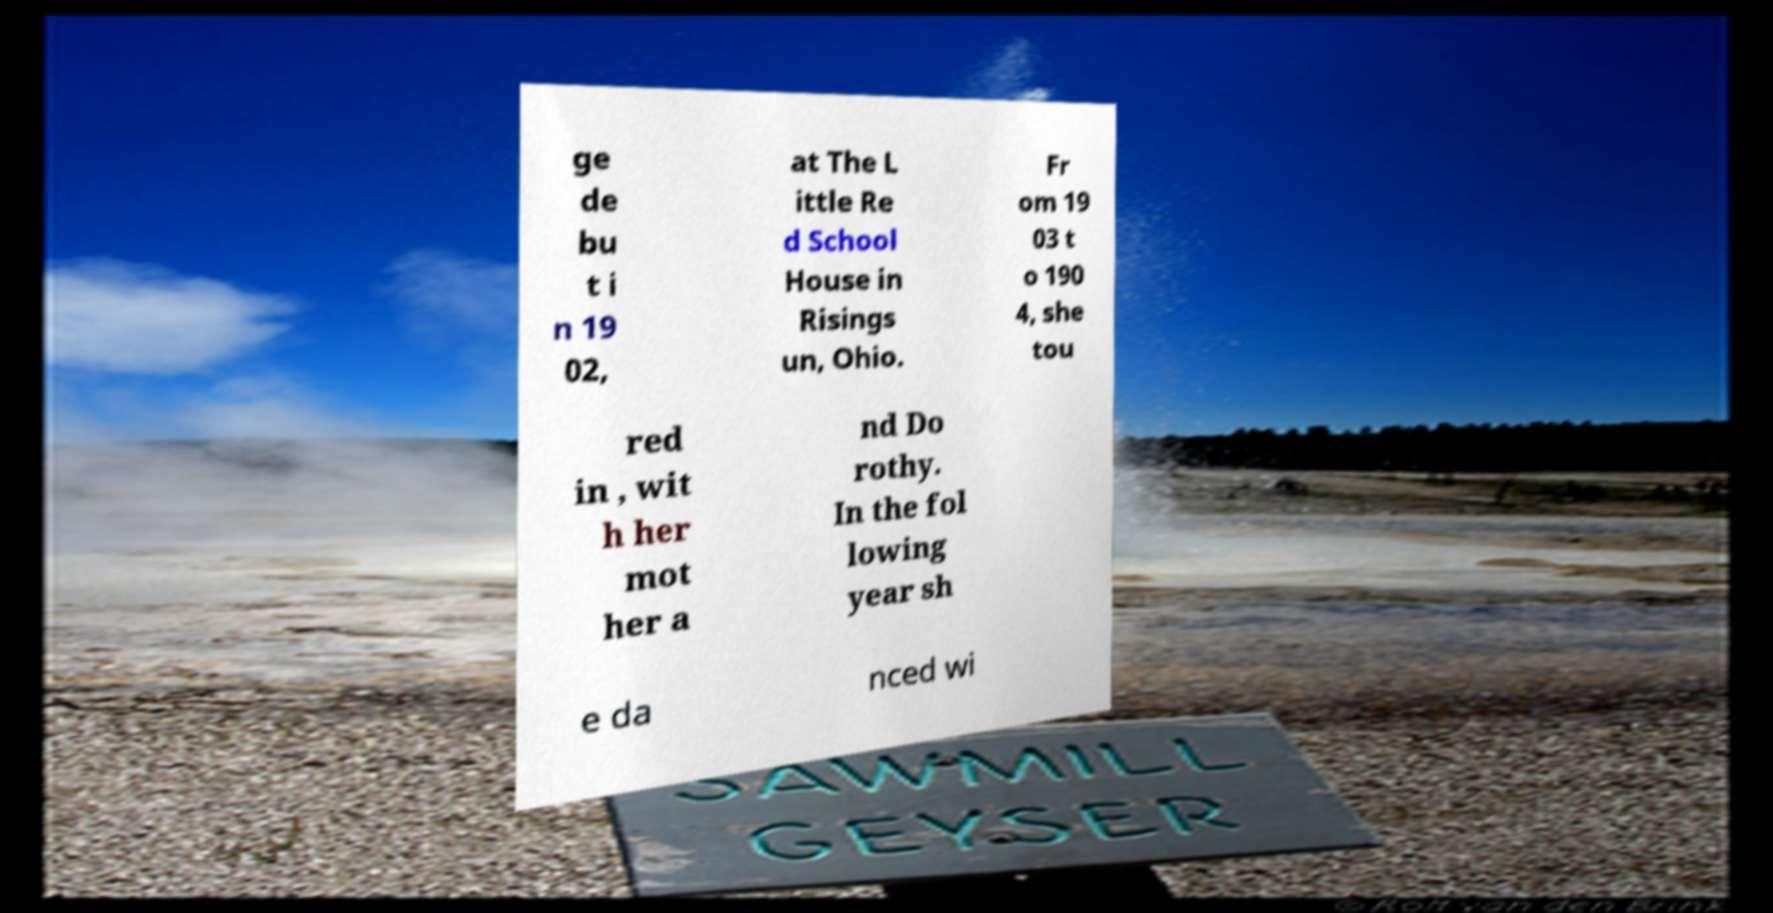What messages or text are displayed in this image? I need them in a readable, typed format. ge de bu t i n 19 02, at The L ittle Re d School House in Risings un, Ohio. Fr om 19 03 t o 190 4, she tou red in , wit h her mot her a nd Do rothy. In the fol lowing year sh e da nced wi 